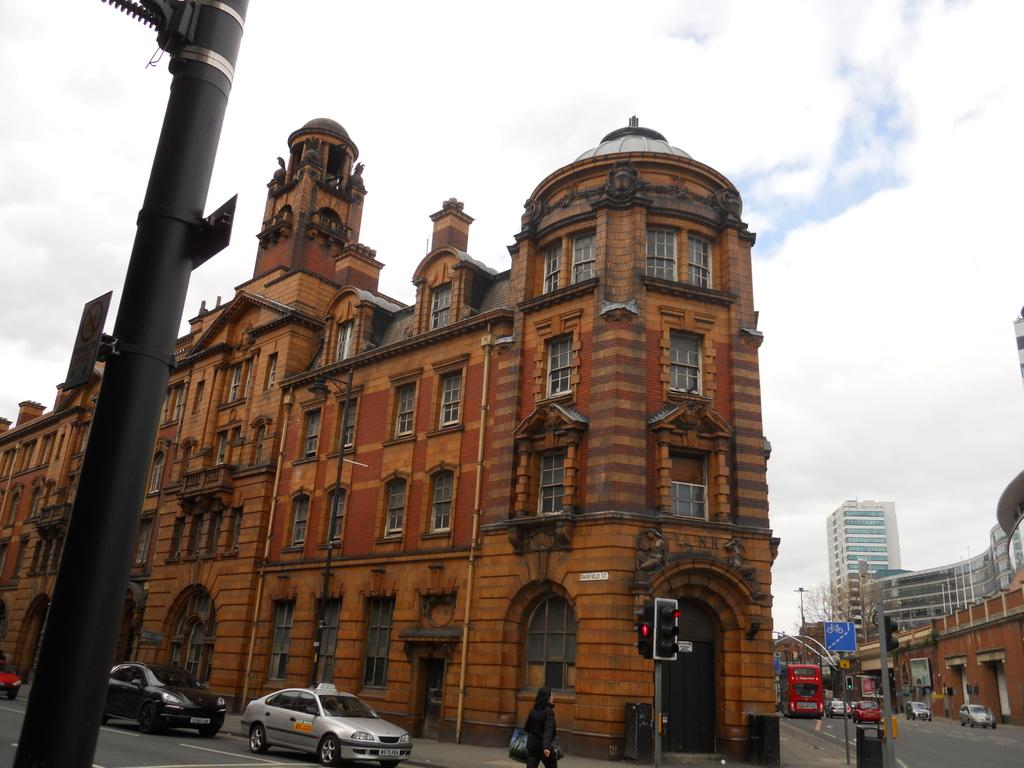What type of structures can be seen in the image? There are buildings in the image. What are the vertical objects in the image? There are poles in the image. What are the flat objects in the image? There are boards in the image. What devices are present to control traffic in the image? There are traffic signals in the image. What objects are available for waste disposal in the image? There are bins in the image. Who is present in the image? There is a person in the image. What types of vehicles can be seen on the road in the image? There are vehicles on the road in the image. What is visible in the background of the image? The sky is visible in the background of the image. What can be seen in the sky in the image? There are clouds in the sky. What type of zephyr can be seen blowing through the image? There is no zephyr present in the image; it is a term used to describe a gentle breeze, which cannot be seen. What scientific experiments are being conducted in the image? There is no indication of any scientific experiments being conducted in the image. Is there snow visible in the image? There is no snow present in the image; it is not mentioned in the provided facts. 